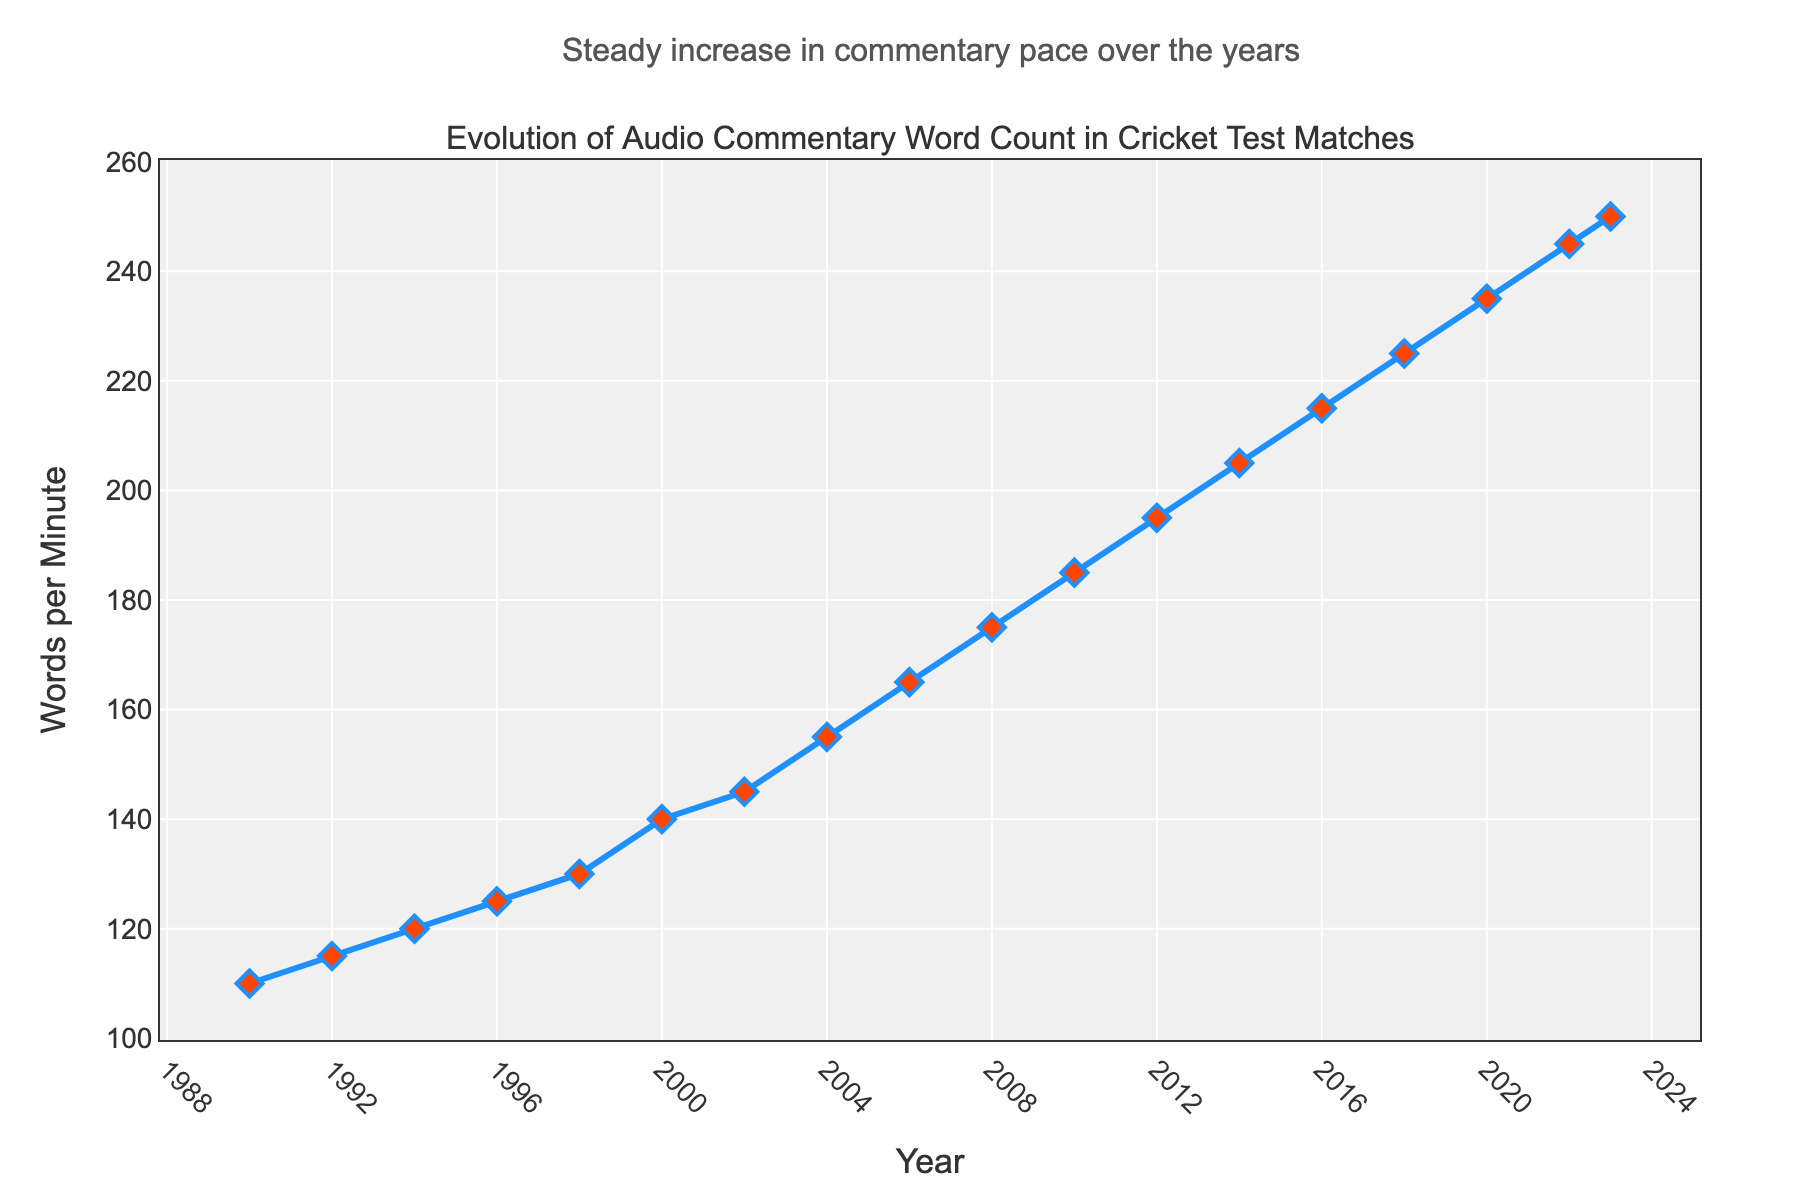How does the word count per minute in 2020 compare to that in 2018? The word count per minute in 2020 is 235, while in 2018 it is 225. The difference is 235 - 225 = 10.
Answer: Word count per minute increased by 10 What year had the highest word count per minute and what was the count? The highest word count per minute is in 2023, which is 250 words per minute.
Answer: 2023, 250 What is the average word count per minute from 1990 to 2000? Sum the word counts from 1990 to 2000 (110 + 115 + 120 + 125 + 130 + 140) which equals 740. There are 6 years in this period, so divide 740 by 6. The average is 740/6 ≈ 123.33 words per minute.
Answer: 123.33 How much did the word count per minute increase from 1990 to 2000? The word count in 1990 was 110 words per minute and in 2000 was 140 words per minute. The increase is 140 - 110 = 30 words per minute.
Answer: 30 words per minute Between which two consecutive years was the largest increase in word count per minute, and what was the increase? The largest increase was between 2018 and 2020, where word count increased from 225 to 235 words per minute. The increase is 235 - 225 = 10 words per minute.
Answer: 2018-2020, 10 words per minute What is the trend of the word count per minute over the years? The trend shows a steady increase in the word count per minute in cricket test matches from 1990 to 2023.
Answer: Steady increase What is the total word count per minute accumulated between 2010 and 2020? Sum the word counts from 2010 to 2020 (185 + 195 + 205 + 215 + 225 + 235) which equals 1260 words per minute.
Answer: 1260 words per minute What was the word count per minute in 2014, and how does it compare to that in 2004? The word count per minute in 2014 was 205, while in 2004 it was 155. The difference is 205 - 155 = 50 words per minute.
Answer: 50 words per minute more Calculate the rate of change in word count per minute per year from 1990 to 2000. Calculate the change in word count from 1990 to 2000 (140 - 110 = 30 words per minute). There are 10 years between 1990 and 2000. Divide the change by the number of years: 30/10 = 3 words per minute per year.
Answer: 3 words per minute per year 